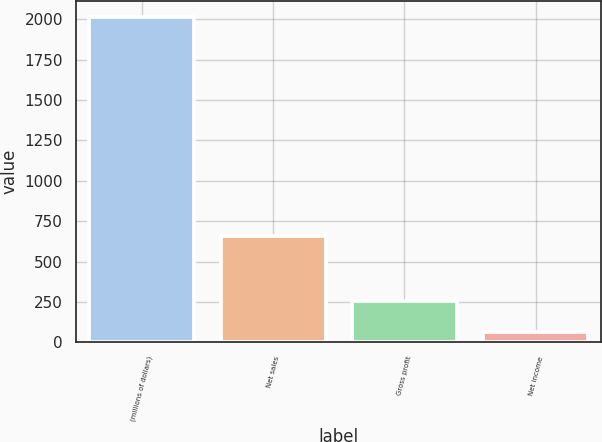Convert chart to OTSL. <chart><loc_0><loc_0><loc_500><loc_500><bar_chart><fcel>(millions of dollars)<fcel>Net sales<fcel>Gross profit<fcel>Net income<nl><fcel>2011<fcel>655.2<fcel>256.54<fcel>61.6<nl></chart> 